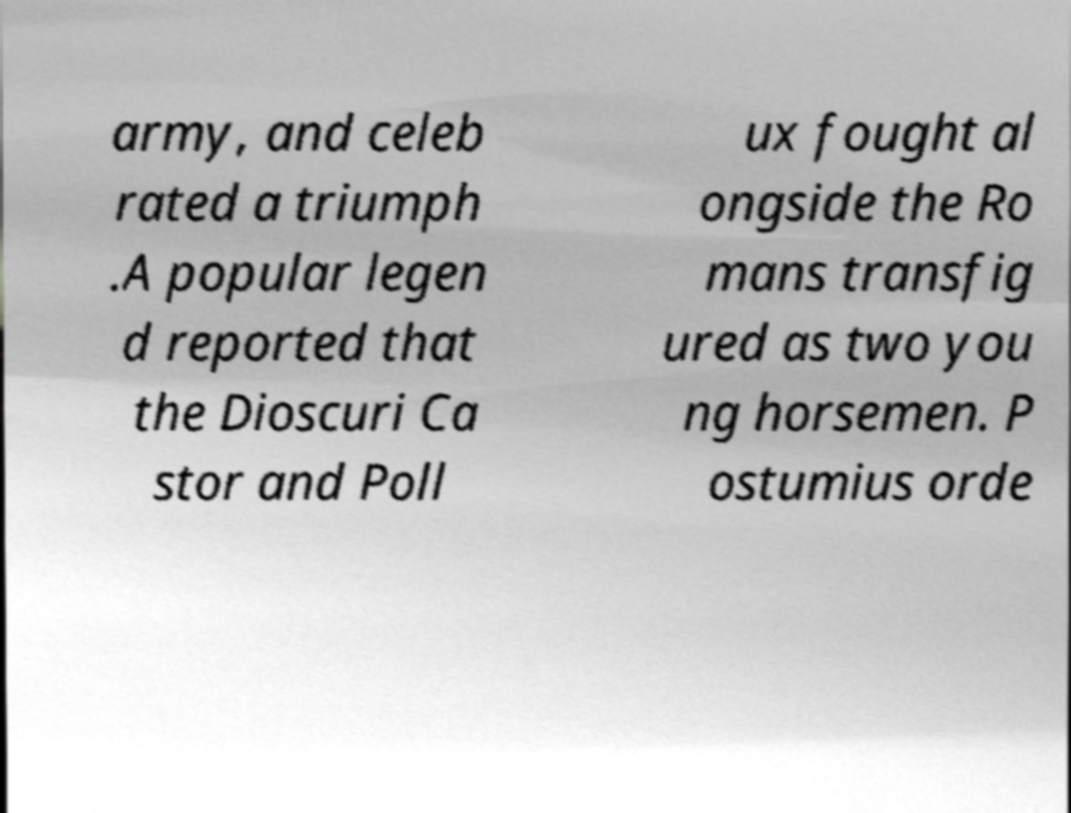I need the written content from this picture converted into text. Can you do that? army, and celeb rated a triumph .A popular legen d reported that the Dioscuri Ca stor and Poll ux fought al ongside the Ro mans transfig ured as two you ng horsemen. P ostumius orde 